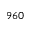Convert formula to latex. <formula><loc_0><loc_0><loc_500><loc_500>9 6 0</formula> 